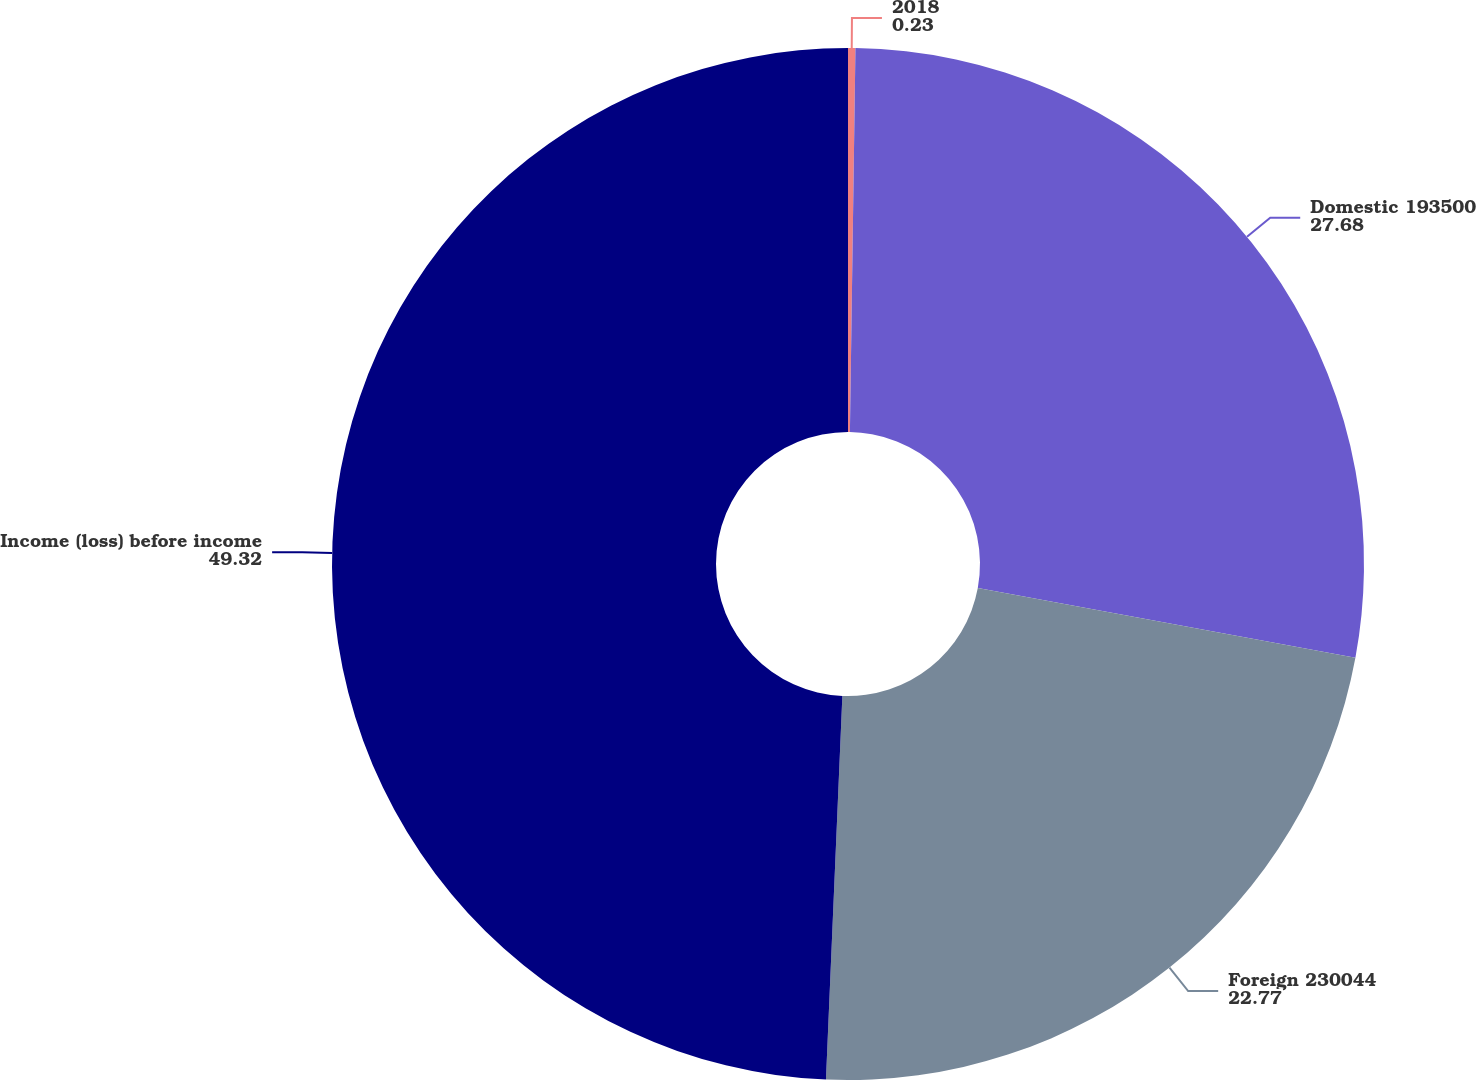<chart> <loc_0><loc_0><loc_500><loc_500><pie_chart><fcel>2018<fcel>Domestic 193500<fcel>Foreign 230044<fcel>Income (loss) before income<nl><fcel>0.23%<fcel>27.68%<fcel>22.77%<fcel>49.32%<nl></chart> 